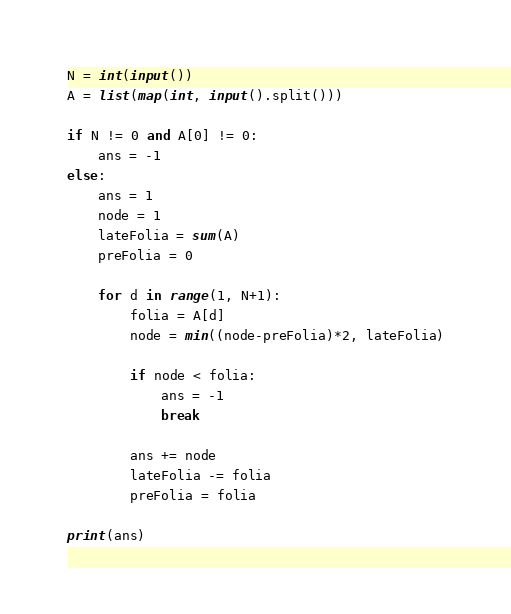Convert code to text. <code><loc_0><loc_0><loc_500><loc_500><_Python_>N = int(input())
A = list(map(int, input().split()))

if N != 0 and A[0] != 0:
    ans = -1
else:
    ans = 1
    node = 1
    lateFolia = sum(A)
    preFolia = 0

    for d in range(1, N+1):
        folia = A[d]
        node = min((node-preFolia)*2, lateFolia)

        if node < folia:
            ans = -1
            break

        ans += node
        lateFolia -= folia
        preFolia = folia

print(ans)
</code> 